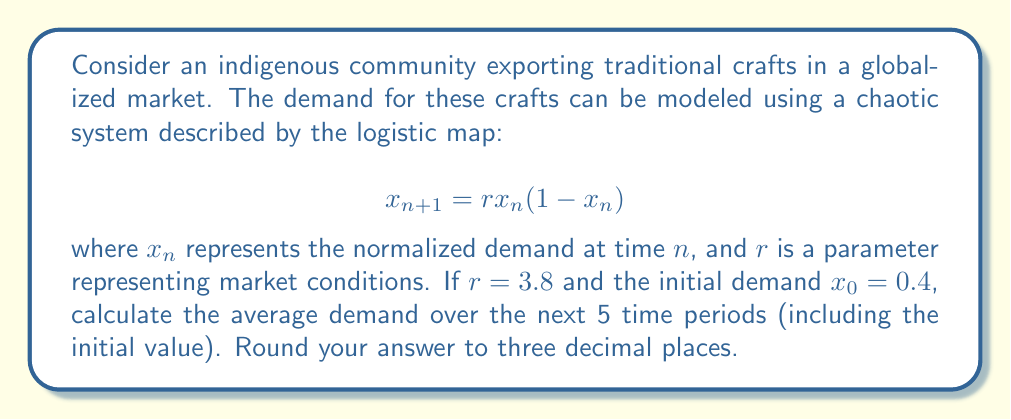Can you answer this question? To solve this problem, we need to iterate the logistic map for 5 time periods and then calculate the average. Let's go through this step-by-step:

1) We start with $r = 3.8$ and $x_0 = 0.4$

2) Let's calculate the next 4 iterations:

   For $n = 1$: $x_1 = 3.8 * 0.4 * (1-0.4) = 0.912$
   
   For $n = 2$: $x_2 = 3.8 * 0.912 * (1-0.912) = 0.305088$
   
   For $n = 3$: $x_3 = 3.8 * 0.305088 * (1-0.305088) = 0.805234$
   
   For $n = 4$: $x_4 = 3.8 * 0.805234 * (1-0.805234) = 0.595613$

3) Now we have 5 values: 0.4, 0.912, 0.305088, 0.805234, 0.595613

4) To calculate the average, we sum these values and divide by 5:

   $\text{Average} = \frac{0.4 + 0.912 + 0.305088 + 0.805234 + 0.595613}{5} = 0.603587$

5) Rounding to three decimal places: 0.604

This average represents the expected demand over the next 5 time periods, which can help the indigenous community plan their production and adapt to market fluctuations in a globalized economy.
Answer: 0.604 